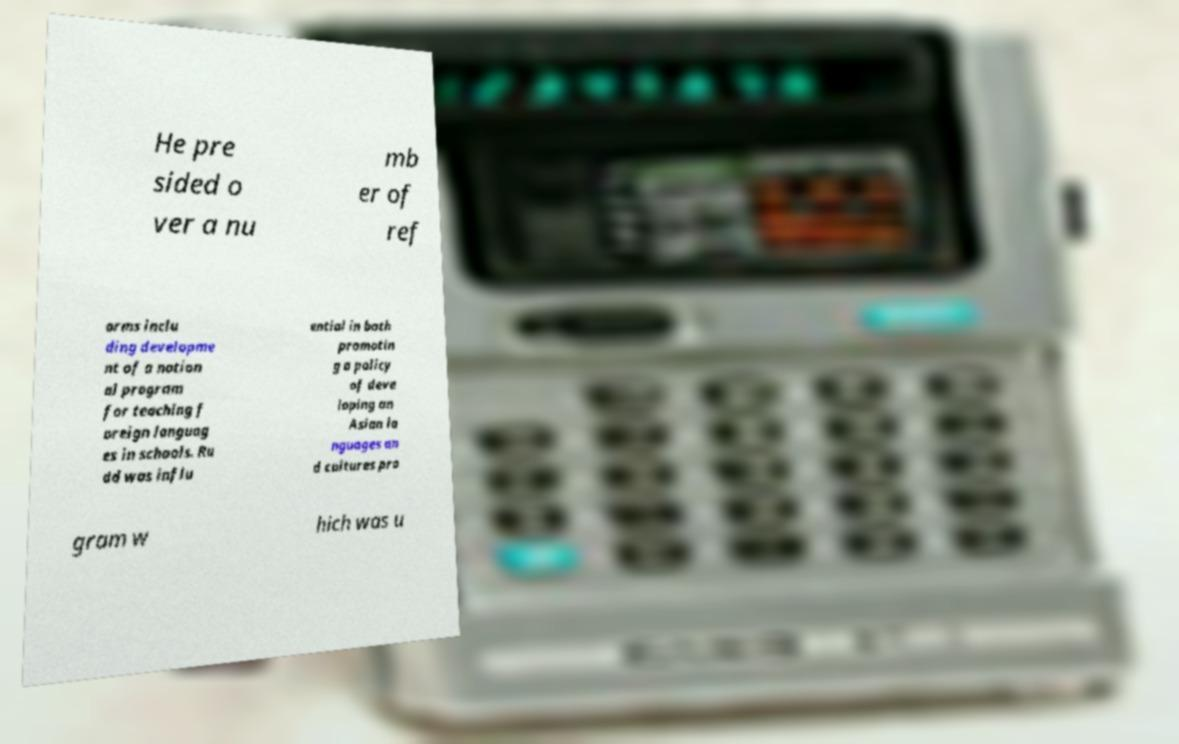Please read and relay the text visible in this image. What does it say? He pre sided o ver a nu mb er of ref orms inclu ding developme nt of a nation al program for teaching f oreign languag es in schools. Ru dd was influ ential in both promotin g a policy of deve loping an Asian la nguages an d cultures pro gram w hich was u 